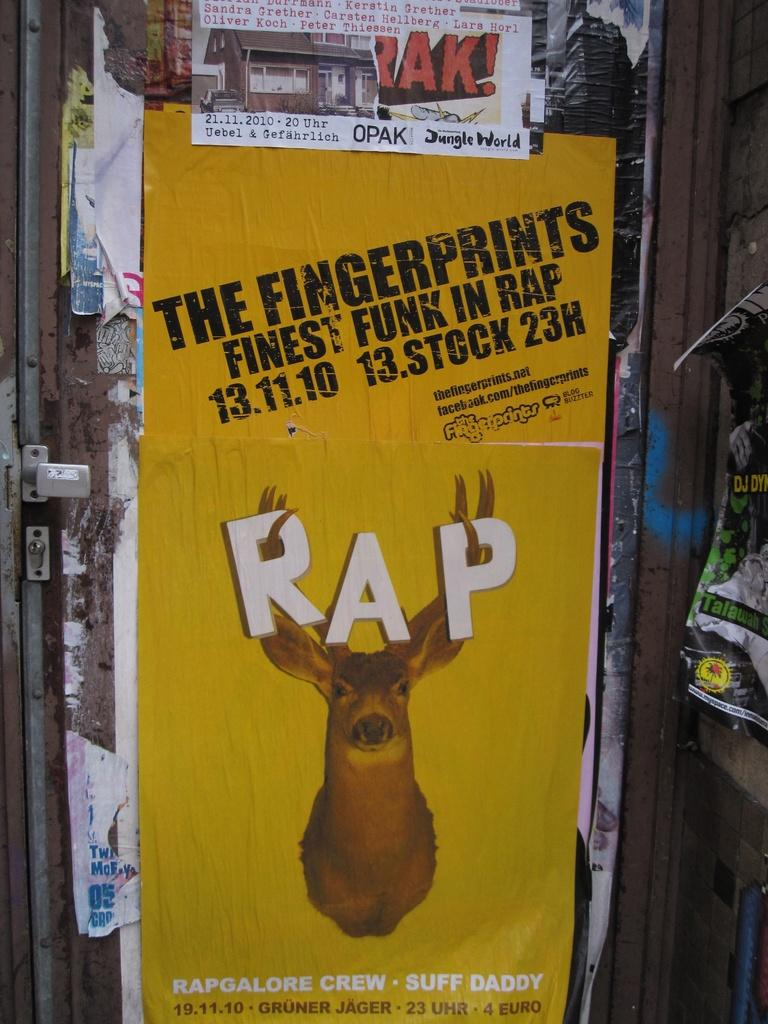What can be found on the door in the image? There is a poster on the door in the image. What is featured on the poster? The poster contains text and an image. What is located beside the door in the image? There is a wall beside the door in the image. What is on the wall beside the door? There is a poster on the wall beside the door. What type of produce is hanging from the string in the image? There is no produce or string present in the image. What appliance is being used to create the image on the poster? The image on the poster is not being created in the image; it is already present on the poster. 